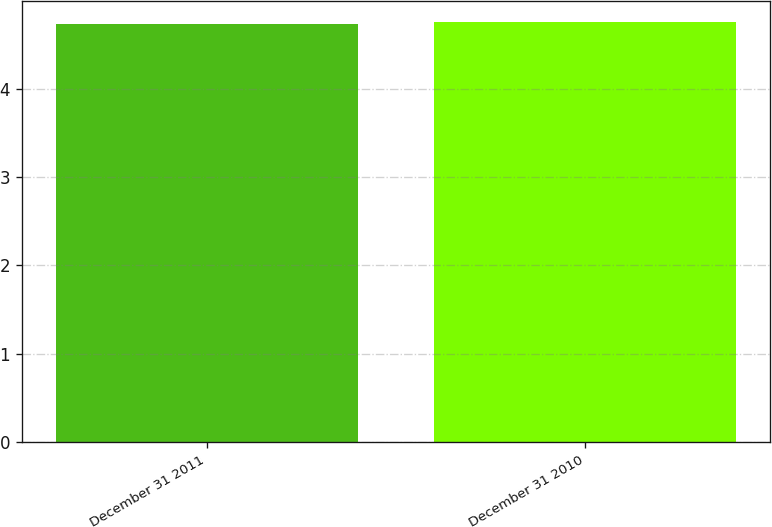Convert chart to OTSL. <chart><loc_0><loc_0><loc_500><loc_500><bar_chart><fcel>December 31 2011<fcel>December 31 2010<nl><fcel>4.73<fcel>4.75<nl></chart> 